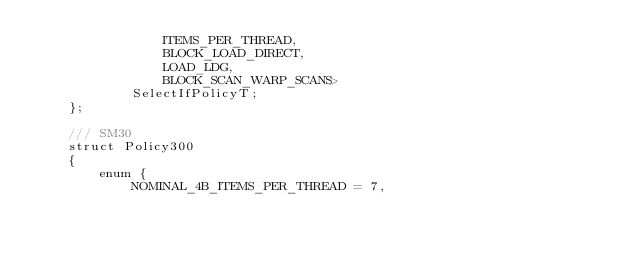Convert code to text. <code><loc_0><loc_0><loc_500><loc_500><_Cuda_>                ITEMS_PER_THREAD,
                BLOCK_LOAD_DIRECT,
                LOAD_LDG,
                BLOCK_SCAN_WARP_SCANS>
            SelectIfPolicyT;
    };

    /// SM30
    struct Policy300
    {
        enum {
            NOMINAL_4B_ITEMS_PER_THREAD = 7,</code> 